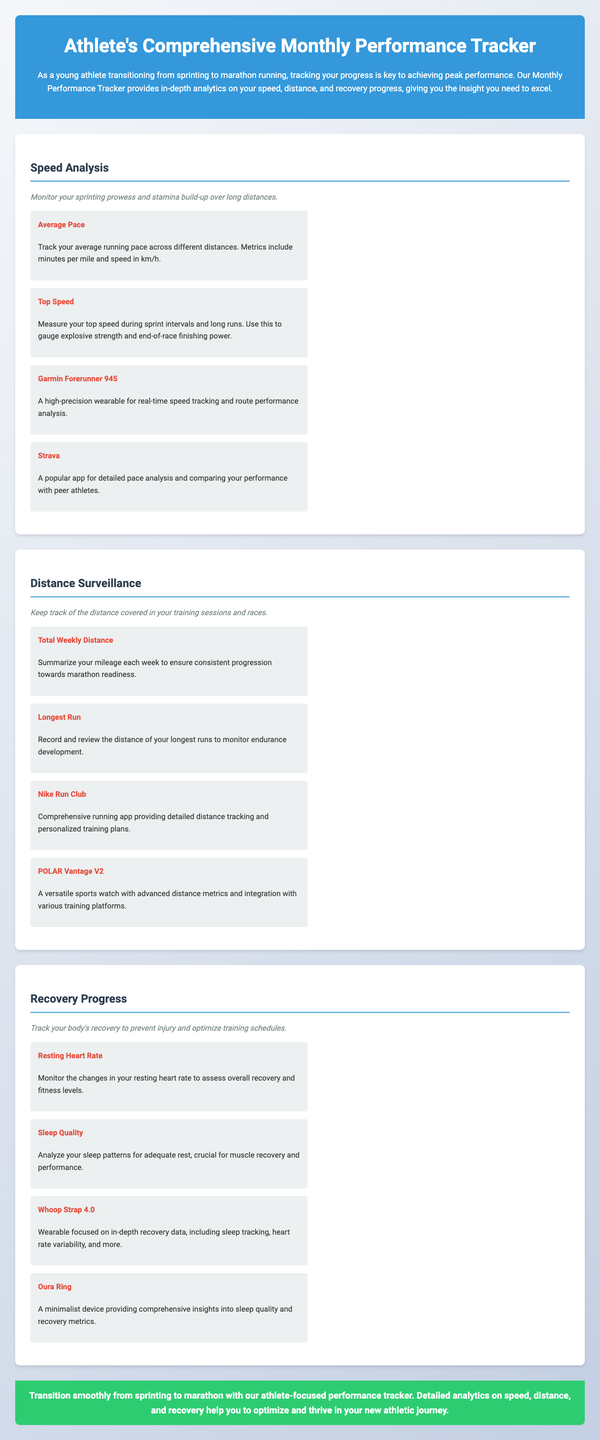what is the title of the document? The title of the document is displayed prominently at the top of the page as "Athlete's Comprehensive Monthly Performance Tracker."
Answer: Athlete's Comprehensive Monthly Performance Tracker what is included in the overview of Speed Analysis? The overview mentions monitoring sprinting prowess and stamina build-up over long distances.
Answer: Monitor your sprinting prowess and stamina build-up over long distances which tool is used for real-time speed tracking? The document lists "Garmin Forerunner 945" as a tool for real-time speed tracking and route performance analysis.
Answer: Garmin Forerunner 945 how does the tracker help with recovery progress? It helps by monitoring changes in resting heart rate and analyzing sleep patterns for adequate rest.
Answer: Monitoring resting heart rate and analyzing sleep patterns what is the key focus of the conclusion? The conclusion emphasizes transitioning smoothly from sprinting to marathon with the help of the performance tracker.
Answer: Transition smoothly from sprinting to marathon with our athlete-focused performance tracker what is the focus of the Distance Surveillance section? The focus is on tracking the distance covered in training sessions and races.
Answer: Keep track of the distance covered in your training sessions and races how does the tool "Whoop Strap 4.0" help athletes? It provides in-depth recovery data, including sleep tracking and heart rate variability.
Answer: Provides in-depth recovery data, including sleep tracking 